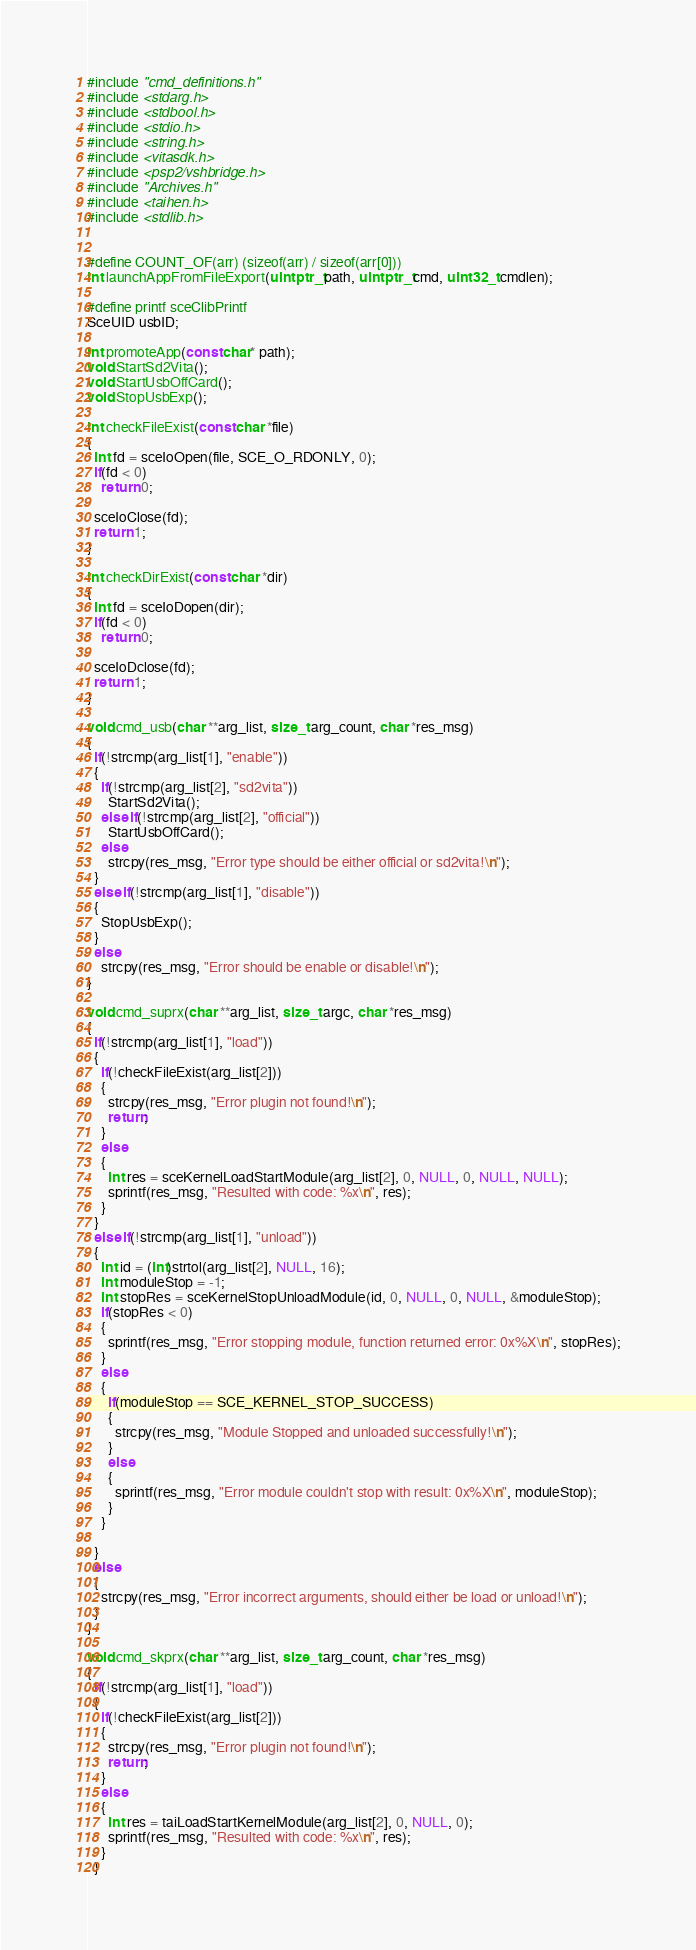Convert code to text. <code><loc_0><loc_0><loc_500><loc_500><_C_>#include "cmd_definitions.h"
#include <stdarg.h>
#include <stdbool.h>
#include <stdio.h>
#include <string.h>
#include <vitasdk.h>
#include <psp2/vshbridge.h>
#include "Archives.h"
#include <taihen.h>
#include <stdlib.h>


#define COUNT_OF(arr) (sizeof(arr) / sizeof(arr[0]))
int launchAppFromFileExport(uintptr_t path, uintptr_t cmd, uint32_t cmdlen);

#define printf sceClibPrintf
SceUID usbID;

int promoteApp(const char* path);
void StartSd2Vita();
void StartUsbOffCard();
void StopUsbExp();

int checkFileExist(const char *file)
{
  int fd = sceIoOpen(file, SCE_O_RDONLY, 0);
  if(fd < 0)
    return 0;
  
  sceIoClose(fd);
  return 1;
}

int checkDirExist(const char *dir)
{
  int fd = sceIoDopen(dir);
  if(fd < 0)
    return 0;
  
  sceIoDclose(fd);
  return 1;
}

void cmd_usb(char **arg_list, size_t arg_count, char *res_msg)
{
  if(!strcmp(arg_list[1], "enable"))
  {
    if(!strcmp(arg_list[2], "sd2vita"))
      StartSd2Vita();
    else if(!strcmp(arg_list[2], "official"))
      StartUsbOffCard();
    else
      strcpy(res_msg, "Error type should be either official or sd2vita!\n");
  }
  else if(!strcmp(arg_list[1], "disable"))
  {
    StopUsbExp();
  }
  else
    strcpy(res_msg, "Error should be enable or disable!\n");
}

void cmd_suprx(char **arg_list, size_t argc, char *res_msg)
{
  if(!strcmp(arg_list[1], "load"))
  {
    if(!checkFileExist(arg_list[2]))
    {
      strcpy(res_msg, "Error plugin not found!\n");
      return;
    }
    else
    {
      int res = sceKernelLoadStartModule(arg_list[2], 0, NULL, 0, NULL, NULL);
      sprintf(res_msg, "Resulted with code: %x\n", res);
    }
  }
  else if(!strcmp(arg_list[1], "unload"))
  {
    int id = (int)strtol(arg_list[2], NULL, 16);
    int moduleStop = -1;
    int stopRes = sceKernelStopUnloadModule(id, 0, NULL, 0, NULL, &moduleStop);
    if(stopRes < 0)
    {
      sprintf(res_msg, "Error stopping module, function returned error: 0x%X\n", stopRes);
    }
    else
    {
      if(moduleStop == SCE_KERNEL_STOP_SUCCESS)
      {
        strcpy(res_msg, "Module Stopped and unloaded successfully!\n");
      }
      else
      {
        sprintf(res_msg, "Error module couldn't stop with result: 0x%X\n", moduleStop);
      }
    }
    
  }
  else
  {
    strcpy(res_msg, "Error incorrect arguments, should either be load or unload!\n");
  }
}

void cmd_skprx(char **arg_list, size_t arg_count, char *res_msg)
{
  if(!strcmp(arg_list[1], "load"))
  {
    if(!checkFileExist(arg_list[2]))
    {
      strcpy(res_msg, "Error plugin not found!\n");
      return;
    }
    else
    {
      int res = taiLoadStartKernelModule(arg_list[2], 0, NULL, 0);
      sprintf(res_msg, "Resulted with code: %x\n", res);
    }
  }</code> 